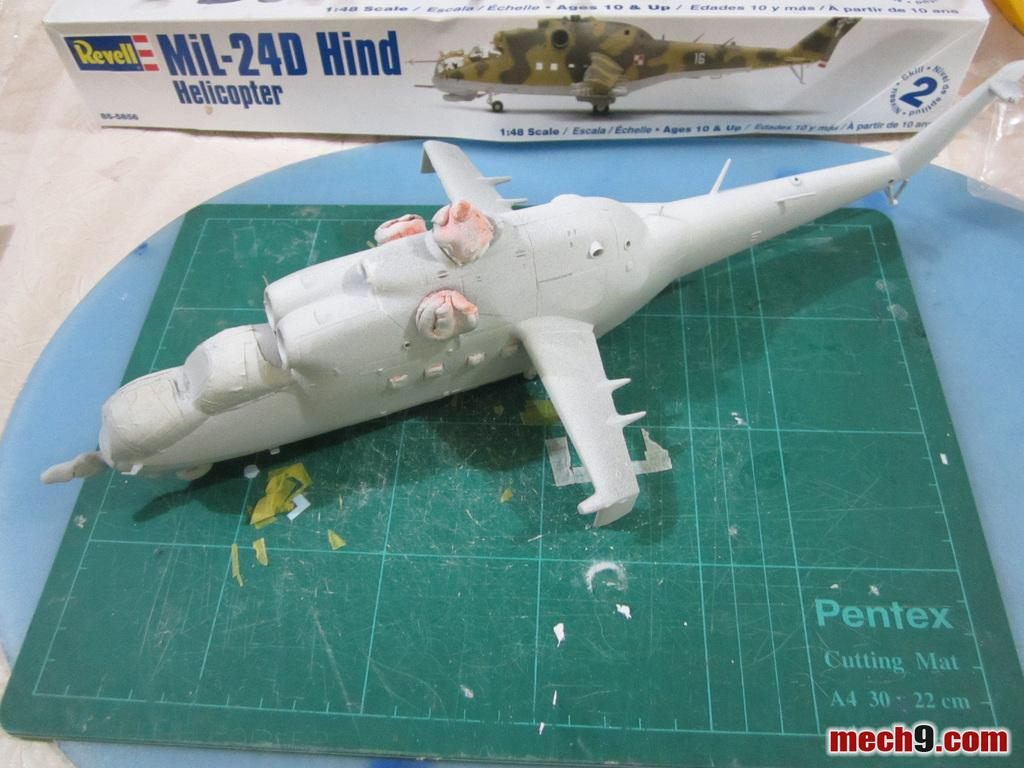<image>
Summarize the visual content of the image. the model airplane is made by the brand Revell 